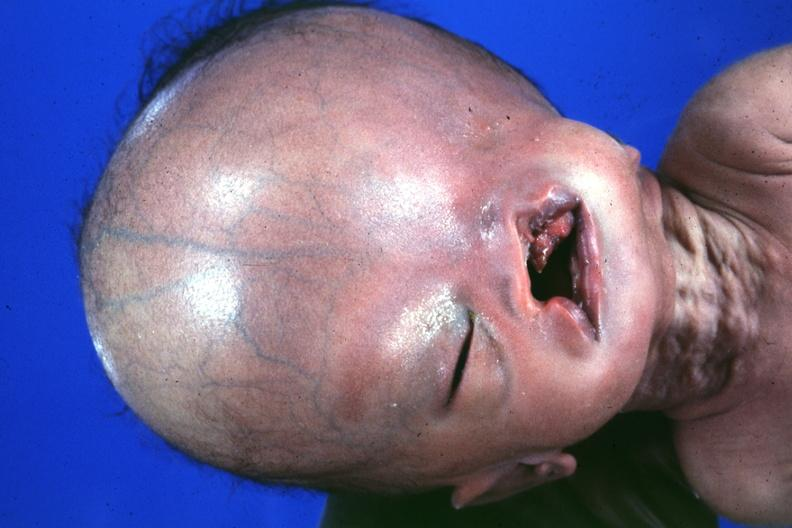what large head see protocol for details?
Answer the question using a single word or phrase. Absence of palpebral fissure cleft palate 